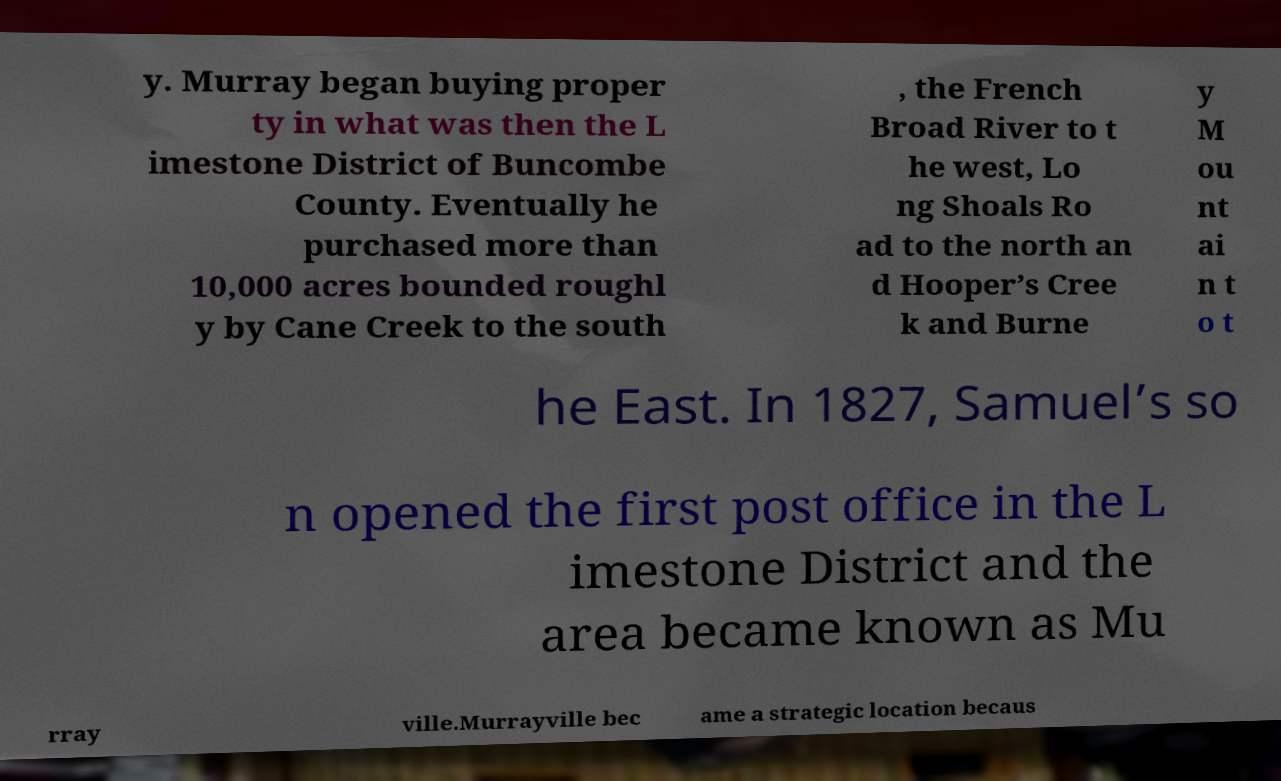There's text embedded in this image that I need extracted. Can you transcribe it verbatim? y. Murray began buying proper ty in what was then the L imestone District of Buncombe County. Eventually he purchased more than 10,000 acres bounded roughl y by Cane Creek to the south , the French Broad River to t he west, Lo ng Shoals Ro ad to the north an d Hooper’s Cree k and Burne y M ou nt ai n t o t he East. In 1827, Samuel’s so n opened the first post office in the L imestone District and the area became known as Mu rray ville.Murrayville bec ame a strategic location becaus 